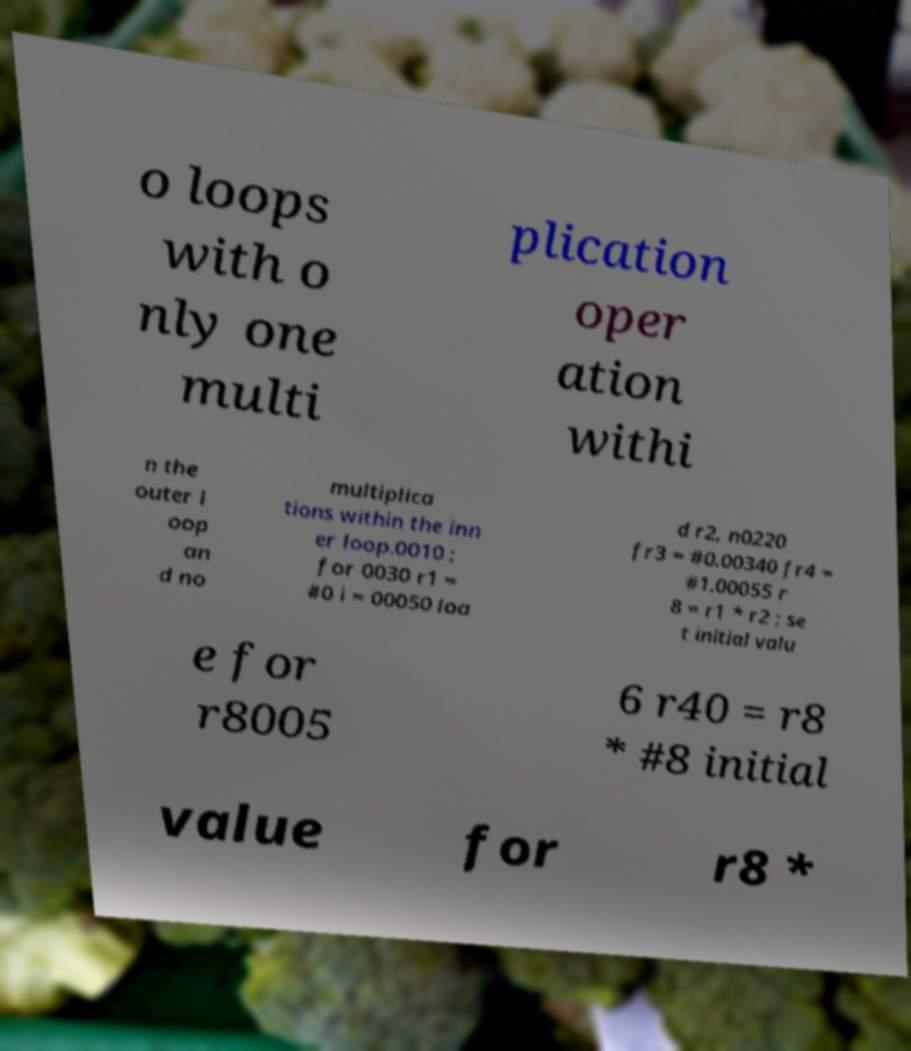Can you read and provide the text displayed in the image?This photo seems to have some interesting text. Can you extract and type it out for me? o loops with o nly one multi plication oper ation withi n the outer l oop an d no multiplica tions within the inn er loop.0010 ; for 0030 r1 = #0 i = 00050 loa d r2, n0220 fr3 = #0.00340 fr4 = #1.00055 r 8 = r1 * r2 ; se t initial valu e for r8005 6 r40 = r8 * #8 initial value for r8 * 